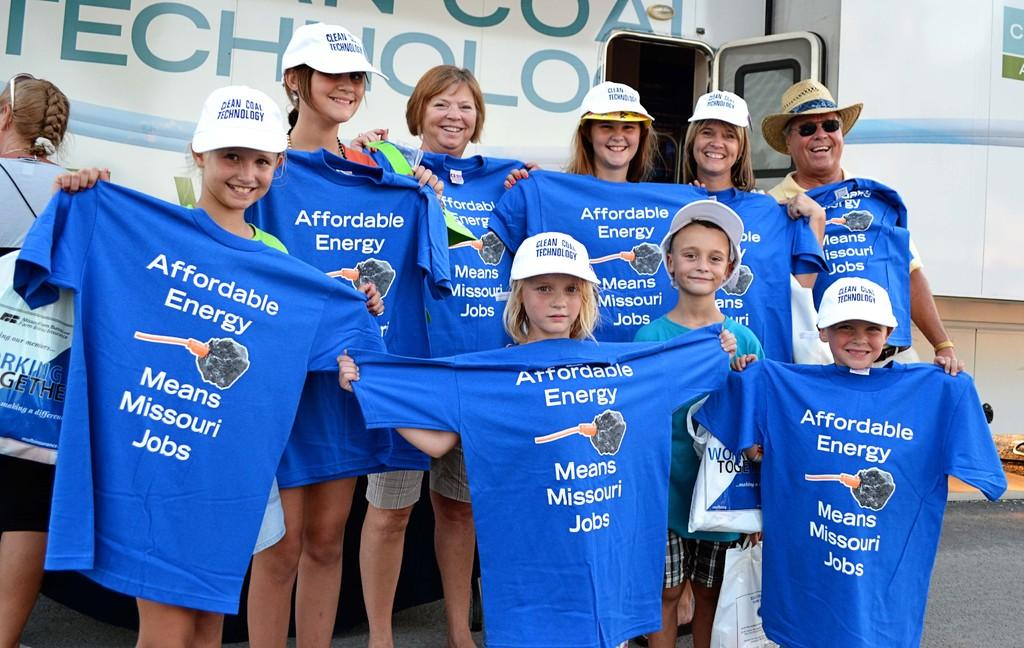Provide a one-sentence caption for the provided image. A group of adults and children holding shirts about affordable energy in Missouri. 